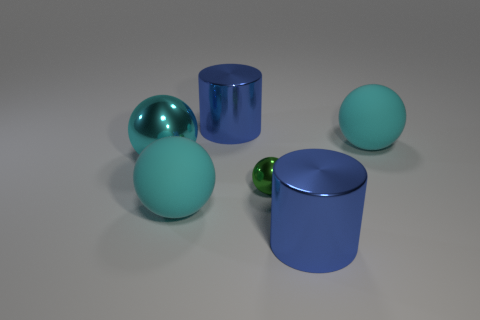There is a blue thing left of the small green metal thing; what is its size?
Your answer should be compact. Large. What number of other objects are there of the same material as the small object?
Provide a short and direct response. 3. Is there a large matte sphere that is behind the large matte thing that is in front of the cyan shiny sphere?
Provide a succinct answer. Yes. There is another shiny thing that is the same shape as the tiny green object; what is its color?
Offer a very short reply. Cyan. What size is the cyan shiny ball?
Offer a terse response. Large. Is the number of big cylinders to the left of the big cyan metal thing less than the number of large blue things?
Provide a short and direct response. Yes. Is the tiny green thing made of the same material as the cyan ball that is in front of the tiny sphere?
Ensure brevity in your answer.  No. Are there any big blue metal cylinders that are behind the rubber object behind the big cyan metal ball that is behind the green shiny ball?
Ensure brevity in your answer.  Yes. Are there any other things that are the same size as the green shiny thing?
Your answer should be very brief. No. There is a ball that is the same material as the green thing; what is its color?
Make the answer very short. Cyan. 